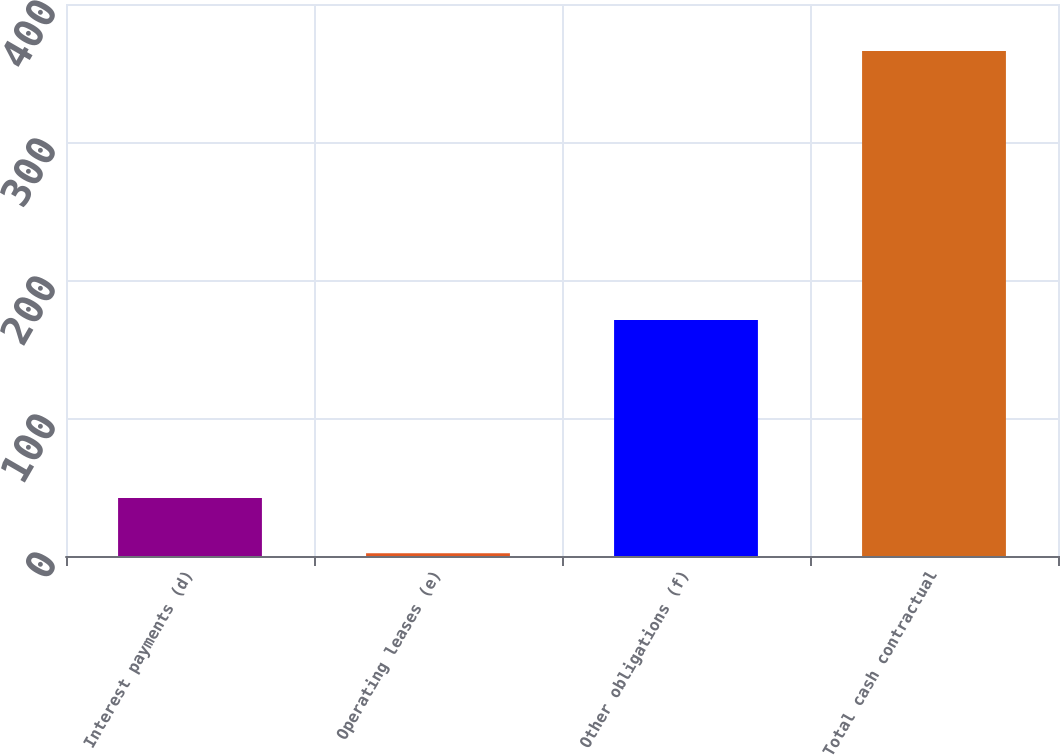Convert chart. <chart><loc_0><loc_0><loc_500><loc_500><bar_chart><fcel>Interest payments (d)<fcel>Operating leases (e)<fcel>Other obligations (f)<fcel>Total cash contractual<nl><fcel>42<fcel>2<fcel>171<fcel>366<nl></chart> 